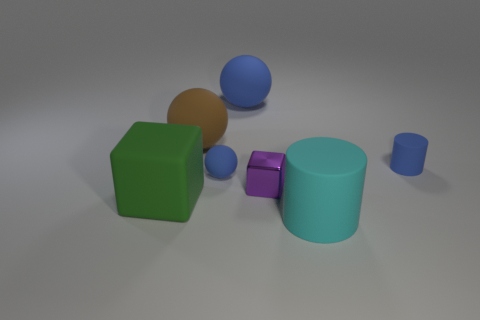What number of tiny yellow metallic cylinders are there?
Provide a succinct answer. 0. What shape is the tiny blue rubber thing on the left side of the cyan cylinder?
Make the answer very short. Sphere. The big thing on the right side of the big matte ball that is right of the tiny rubber thing that is in front of the blue rubber cylinder is what color?
Provide a short and direct response. Cyan. The brown thing that is the same material as the small cylinder is what shape?
Give a very brief answer. Sphere. Is the number of large cyan metallic spheres less than the number of large brown rubber things?
Provide a succinct answer. Yes. Is the purple thing made of the same material as the big blue sphere?
Provide a short and direct response. No. How many other things are the same color as the matte block?
Your answer should be very brief. 0. Is the number of big green rubber blocks greater than the number of spheres?
Ensure brevity in your answer.  No. There is a purple metal thing; is its size the same as the blue ball that is in front of the large blue thing?
Offer a very short reply. Yes. What color is the metal object behind the cyan matte thing?
Keep it short and to the point. Purple. 